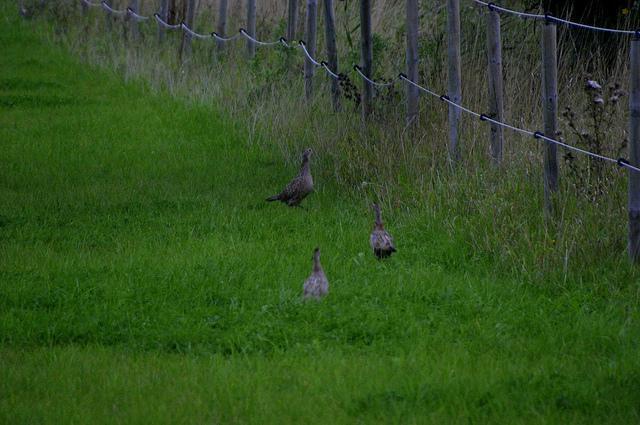How many birds is there?
Give a very brief answer. 3. How many animals are in the yard?
Give a very brief answer. 3. How many legs does the animal have?
Give a very brief answer. 2. How many animals are laying down?
Give a very brief answer. 1. How many animals do you see?
Give a very brief answer. 3. How many brown ducks can you see?
Give a very brief answer. 3. How many birds are there?
Give a very brief answer. 3. How many birds?
Give a very brief answer. 3. How many geese are there?
Give a very brief answer. 3. 